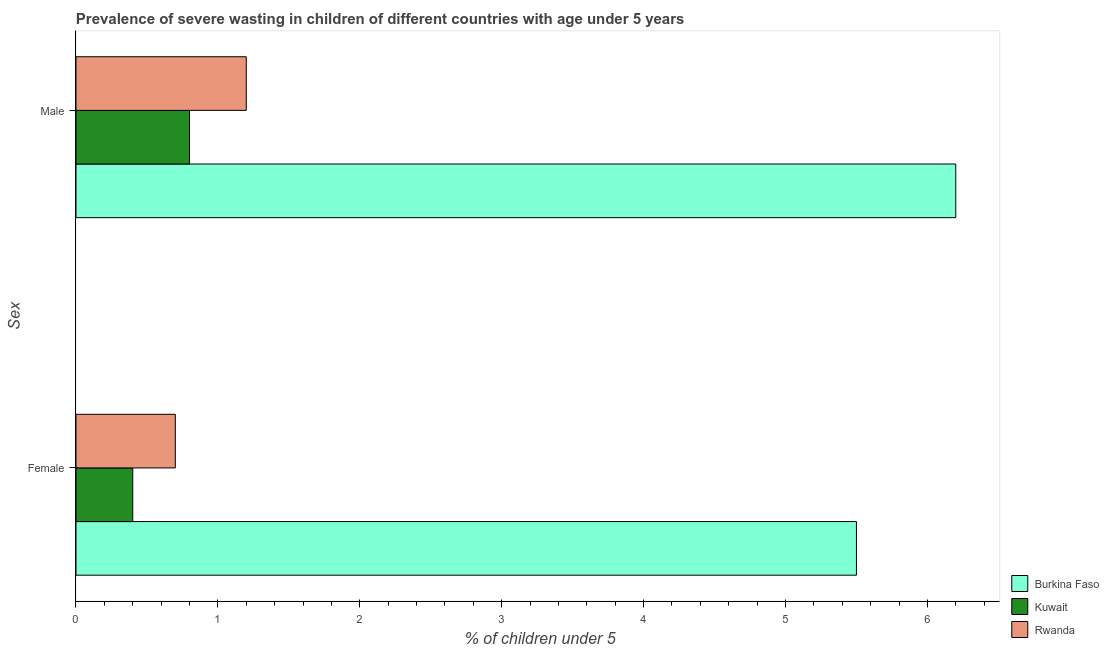How many groups of bars are there?
Your answer should be compact. 2. Are the number of bars per tick equal to the number of legend labels?
Your response must be concise. Yes. Are the number of bars on each tick of the Y-axis equal?
Provide a succinct answer. Yes. How many bars are there on the 1st tick from the bottom?
Your response must be concise. 3. What is the label of the 1st group of bars from the top?
Your answer should be compact. Male. What is the percentage of undernourished female children in Kuwait?
Your answer should be very brief. 0.4. Across all countries, what is the minimum percentage of undernourished male children?
Provide a succinct answer. 0.8. In which country was the percentage of undernourished female children maximum?
Your response must be concise. Burkina Faso. In which country was the percentage of undernourished male children minimum?
Offer a very short reply. Kuwait. What is the total percentage of undernourished male children in the graph?
Ensure brevity in your answer.  8.2. What is the difference between the percentage of undernourished female children in Burkina Faso and that in Kuwait?
Give a very brief answer. 5.1. What is the difference between the percentage of undernourished male children in Rwanda and the percentage of undernourished female children in Kuwait?
Offer a very short reply. 0.8. What is the average percentage of undernourished male children per country?
Provide a short and direct response. 2.73. What is the difference between the percentage of undernourished female children and percentage of undernourished male children in Rwanda?
Offer a very short reply. -0.5. In how many countries, is the percentage of undernourished male children greater than 3 %?
Offer a very short reply. 1. What is the ratio of the percentage of undernourished female children in Rwanda to that in Kuwait?
Make the answer very short. 1.75. Is the percentage of undernourished female children in Kuwait less than that in Rwanda?
Make the answer very short. Yes. In how many countries, is the percentage of undernourished male children greater than the average percentage of undernourished male children taken over all countries?
Your answer should be compact. 1. What does the 1st bar from the top in Male represents?
Your answer should be very brief. Rwanda. What does the 3rd bar from the bottom in Female represents?
Keep it short and to the point. Rwanda. How many bars are there?
Your response must be concise. 6. Does the graph contain grids?
Provide a succinct answer. No. Where does the legend appear in the graph?
Provide a succinct answer. Bottom right. How are the legend labels stacked?
Make the answer very short. Vertical. What is the title of the graph?
Keep it short and to the point. Prevalence of severe wasting in children of different countries with age under 5 years. Does "Guam" appear as one of the legend labels in the graph?
Ensure brevity in your answer.  No. What is the label or title of the X-axis?
Ensure brevity in your answer.   % of children under 5. What is the label or title of the Y-axis?
Provide a succinct answer. Sex. What is the  % of children under 5 in Kuwait in Female?
Offer a terse response. 0.4. What is the  % of children under 5 in Rwanda in Female?
Give a very brief answer. 0.7. What is the  % of children under 5 in Burkina Faso in Male?
Offer a very short reply. 6.2. What is the  % of children under 5 in Kuwait in Male?
Your answer should be very brief. 0.8. What is the  % of children under 5 of Rwanda in Male?
Provide a succinct answer. 1.2. Across all Sex, what is the maximum  % of children under 5 of Burkina Faso?
Give a very brief answer. 6.2. Across all Sex, what is the maximum  % of children under 5 in Kuwait?
Your response must be concise. 0.8. Across all Sex, what is the maximum  % of children under 5 of Rwanda?
Give a very brief answer. 1.2. Across all Sex, what is the minimum  % of children under 5 in Burkina Faso?
Ensure brevity in your answer.  5.5. Across all Sex, what is the minimum  % of children under 5 of Kuwait?
Ensure brevity in your answer.  0.4. Across all Sex, what is the minimum  % of children under 5 of Rwanda?
Give a very brief answer. 0.7. What is the total  % of children under 5 of Burkina Faso in the graph?
Provide a succinct answer. 11.7. What is the total  % of children under 5 in Rwanda in the graph?
Your answer should be very brief. 1.9. What is the difference between the  % of children under 5 of Rwanda in Female and that in Male?
Your answer should be very brief. -0.5. What is the difference between the  % of children under 5 of Burkina Faso in Female and the  % of children under 5 of Rwanda in Male?
Offer a terse response. 4.3. What is the difference between the  % of children under 5 of Kuwait in Female and the  % of children under 5 of Rwanda in Male?
Your answer should be very brief. -0.8. What is the average  % of children under 5 of Burkina Faso per Sex?
Your answer should be compact. 5.85. What is the difference between the  % of children under 5 of Burkina Faso and  % of children under 5 of Rwanda in Female?
Offer a terse response. 4.8. What is the difference between the  % of children under 5 in Burkina Faso and  % of children under 5 in Kuwait in Male?
Provide a short and direct response. 5.4. What is the ratio of the  % of children under 5 in Burkina Faso in Female to that in Male?
Make the answer very short. 0.89. What is the ratio of the  % of children under 5 in Kuwait in Female to that in Male?
Ensure brevity in your answer.  0.5. What is the ratio of the  % of children under 5 of Rwanda in Female to that in Male?
Ensure brevity in your answer.  0.58. What is the difference between the highest and the second highest  % of children under 5 of Rwanda?
Your response must be concise. 0.5. What is the difference between the highest and the lowest  % of children under 5 in Burkina Faso?
Provide a succinct answer. 0.7. What is the difference between the highest and the lowest  % of children under 5 in Kuwait?
Keep it short and to the point. 0.4. 